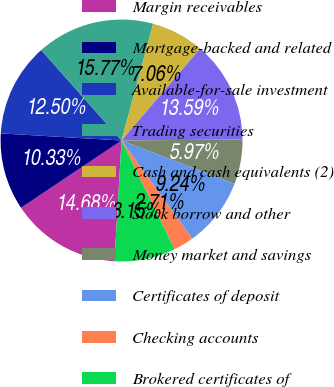Convert chart. <chart><loc_0><loc_0><loc_500><loc_500><pie_chart><fcel>Margin receivables<fcel>Mortgage-backed and related<fcel>Available-for-sale investment<fcel>Trading securities<fcel>Cash and cash equivalents (2)<fcel>Stock borrow and other<fcel>Money market and savings<fcel>Certificates of deposit<fcel>Checking accounts<fcel>Brokered certificates of<nl><fcel>14.68%<fcel>10.33%<fcel>12.5%<fcel>15.77%<fcel>7.06%<fcel>13.59%<fcel>5.97%<fcel>9.24%<fcel>2.71%<fcel>8.15%<nl></chart> 